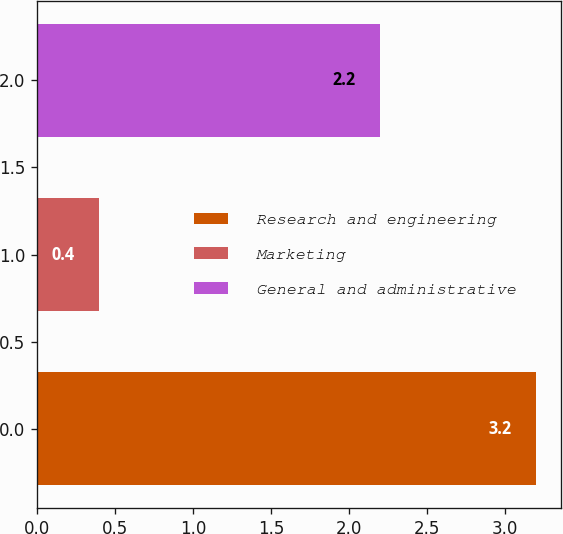<chart> <loc_0><loc_0><loc_500><loc_500><bar_chart><fcel>Research and engineering<fcel>Marketing<fcel>General and administrative<nl><fcel>3.2<fcel>0.4<fcel>2.2<nl></chart> 